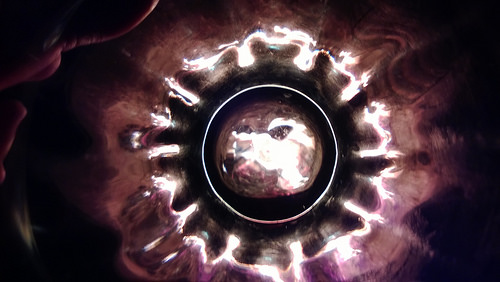<image>
Can you confirm if the light is behind the dark? No. The light is not behind the dark. From this viewpoint, the light appears to be positioned elsewhere in the scene. 